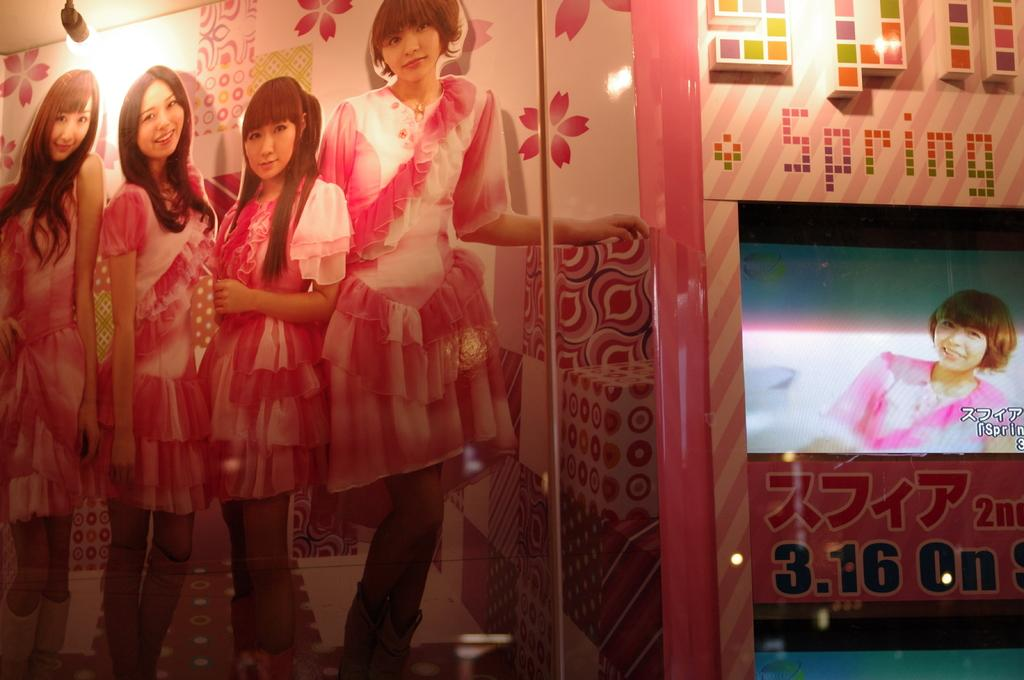How many girls are present in the image? There are five girls in the image. What are the girls doing in the image? Four of the girls are standing, and they are all smiling. What can be seen in the background of the image? There are paintings on the wall in the background of the image. What is the temperature of the room in the image? The temperature of the room cannot be determined from the image, as there is no information provided about the room or the environment. 